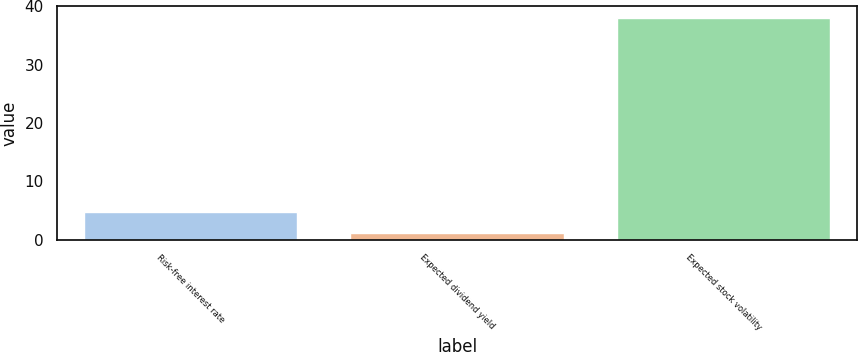Convert chart. <chart><loc_0><loc_0><loc_500><loc_500><bar_chart><fcel>Risk-free interest rate<fcel>Expected dividend yield<fcel>Expected stock volatility<nl><fcel>4.8<fcel>1.1<fcel>38.1<nl></chart> 